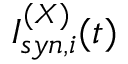<formula> <loc_0><loc_0><loc_500><loc_500>I _ { s y n , i } ^ { ( X ) } ( t )</formula> 